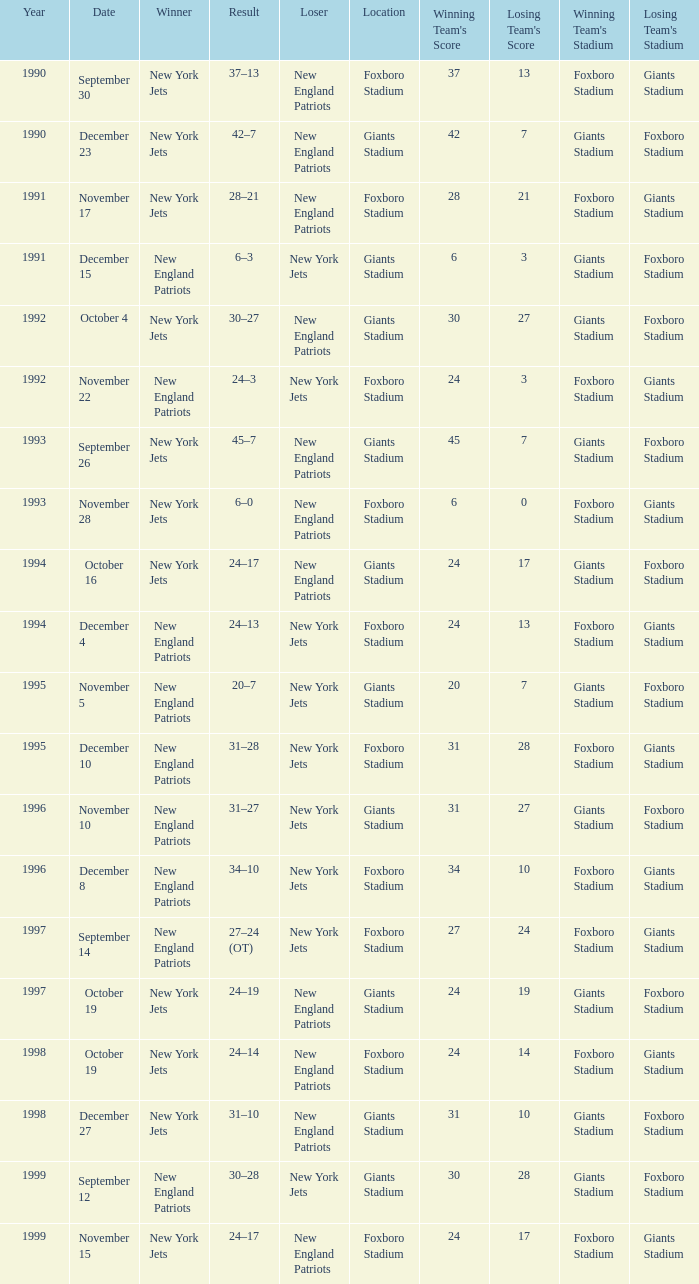What team was the lower when the winner was the new york jets, and a Year earlier than 1994, and a Result of 37–13? New England Patriots. 